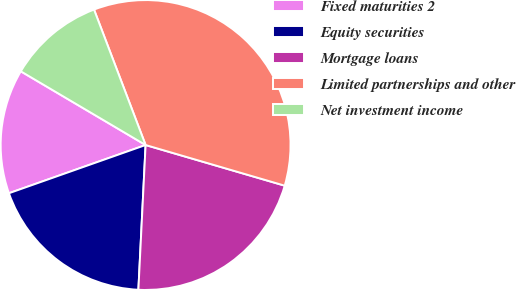Convert chart to OTSL. <chart><loc_0><loc_0><loc_500><loc_500><pie_chart><fcel>Fixed maturities 2<fcel>Equity securities<fcel>Mortgage loans<fcel>Limited partnerships and other<fcel>Net investment income<nl><fcel>13.89%<fcel>18.81%<fcel>21.27%<fcel>35.32%<fcel>10.72%<nl></chart> 